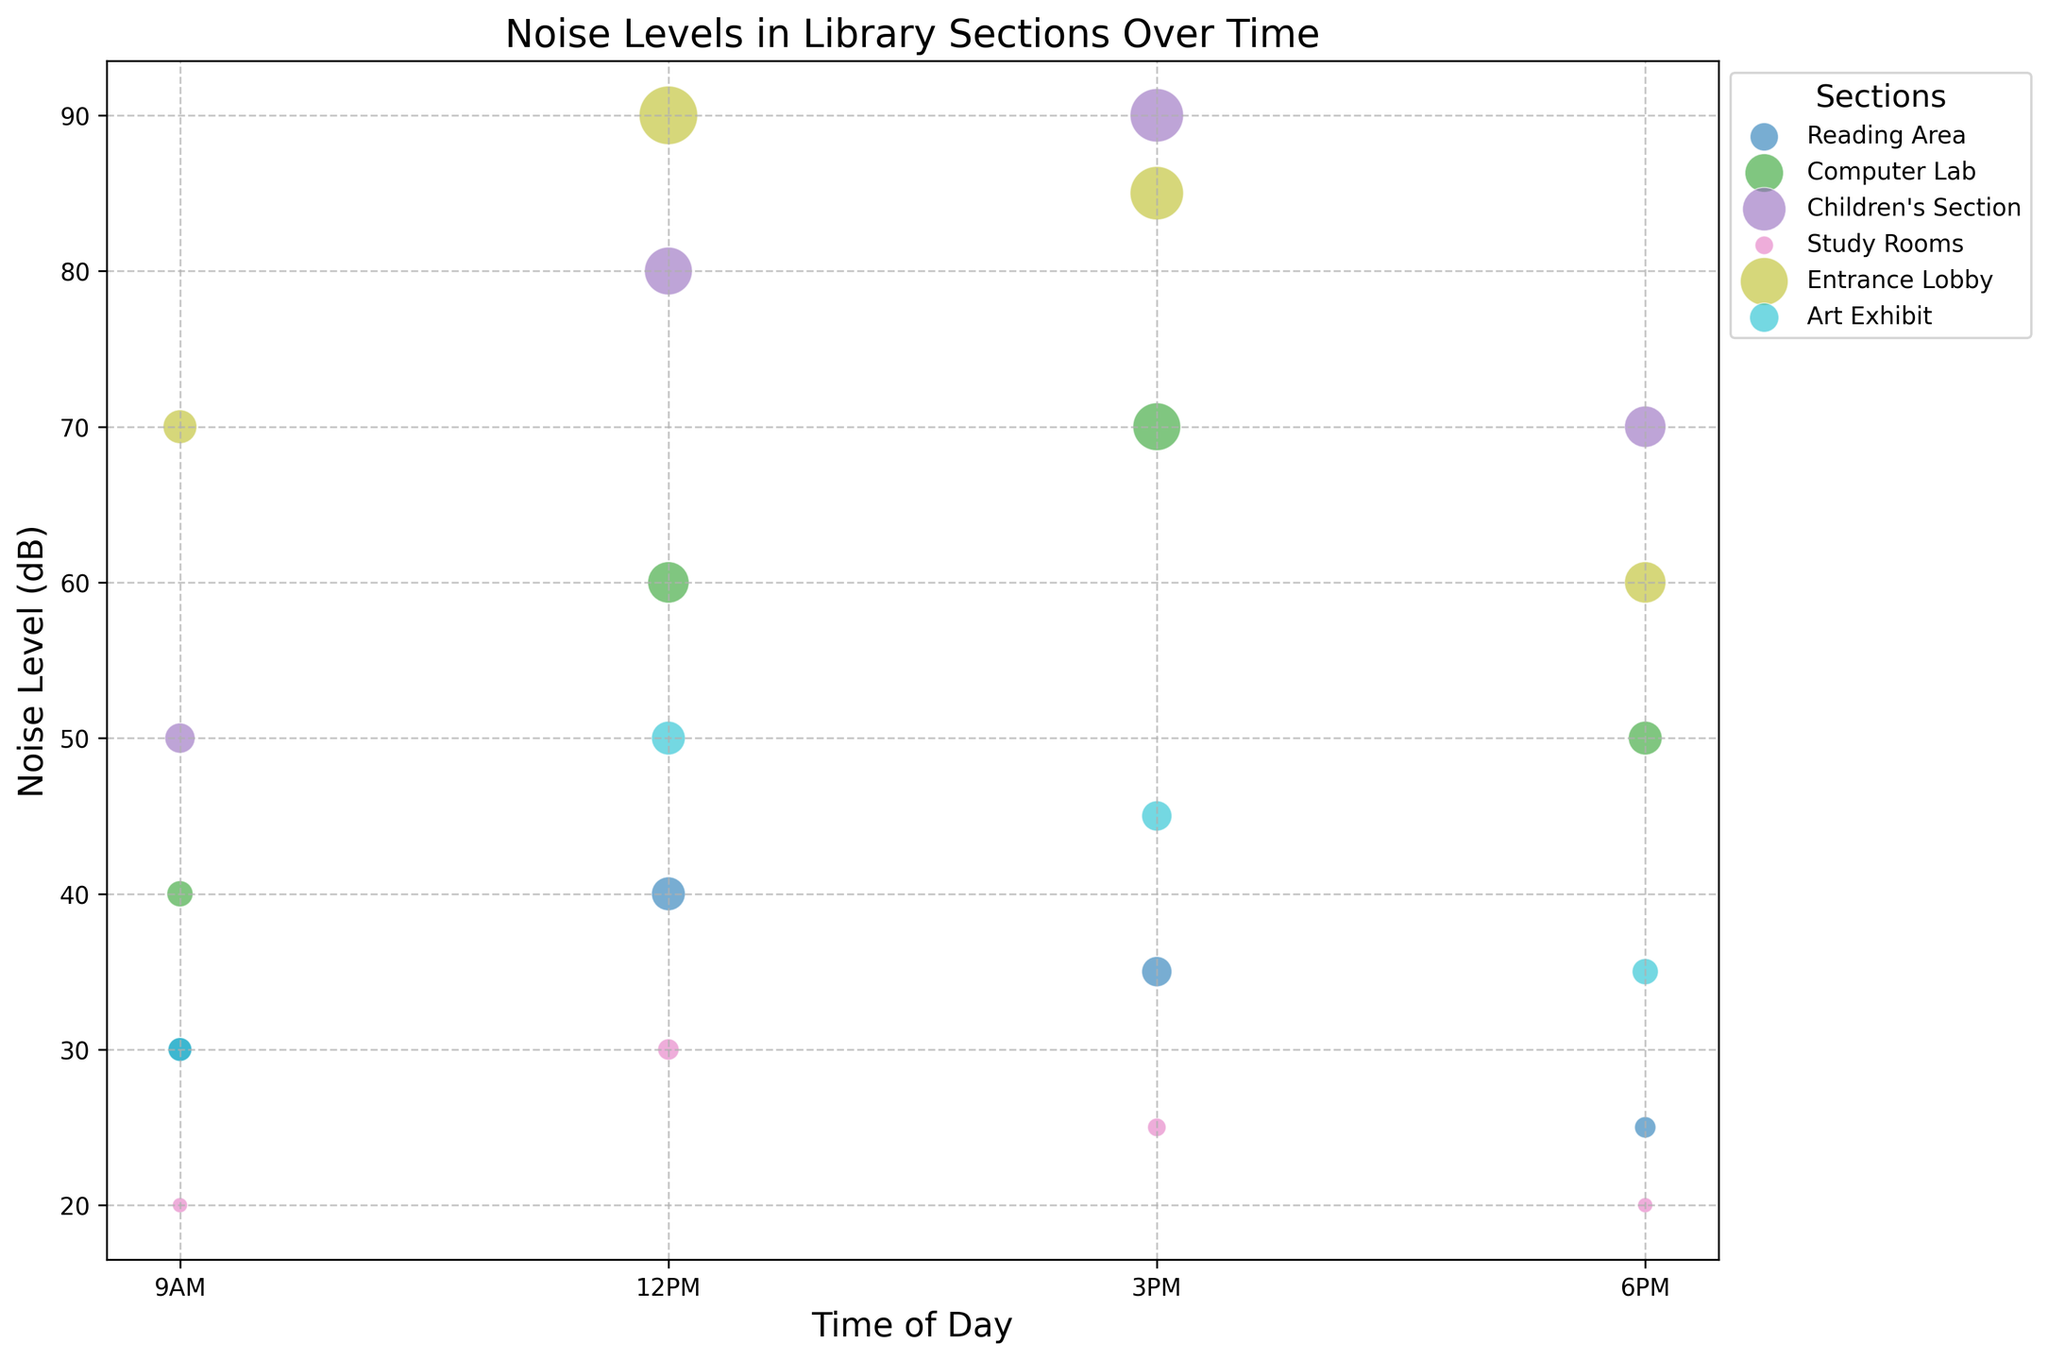Which section has the highest noise level at 12 PM? To find this, look at the size and position of the bubbles at 12 PM for each section and identify the one with the highest noise level on the y-axis. The largest and highest bubble corresponds to the Children's Section.
Answer: Children's Section What is the average noise level in the Computer Lab throughout the day? Add the noise levels at 9 AM, 12 PM, 3 PM, and 6 PM for the Computer Lab and divide by 4. The values are 40 + 60 + 70 + 50 = 220, and the average is 220 / 4 = 55.
Answer: 55 How does the noise level in the Reading Area compare from 9 AM to 6 PM? Look at the bubbles' positions for the Reading Area at 9 AM and 6 PM. The noise level decreases from 30 dB (9 AM) to 25 dB (6 PM).
Answer: Decreases Which section has the least number of people at 3 PM? Look at the size of the bubbles at 3 PM. The smallest bubble corresponds to the Study Rooms.
Answer: Study Rooms What is the difference in noise levels between the Entrance Lobby and the Art Exhibit at 12 PM? Identify the noise levels for both sections at 12 PM. The values are 90 dB (Entrance Lobby) and 50 dB (Art Exhibit). The difference is 90 - 50 = 40.
Answer: 40 Which section has the most consistent noise levels throughout the day? Consistency can be observed by looking for a section where the bubbles are almost level horizontally on the chart. The Study Rooms show noise levels of 20, 30, 25, and 20, which are relatively consistent.
Answer: Study Rooms What's the total number of people represented in the Entrance Lobby across all times? Add the number of people at 9 AM, 12 PM, 3 PM, and 6 PM in the Entrance Lobby. The values are 10 + 30 + 25 + 15 = 80.
Answer: 80 Which section has the second highest noise level at 3 PM? Look at the positions of the bubbles at 3 PM to identify the second highest noise level. The second highest noise level after Children's Section (90 dB) is in the Computer Lab (70 dB).
Answer: Computer Lab 